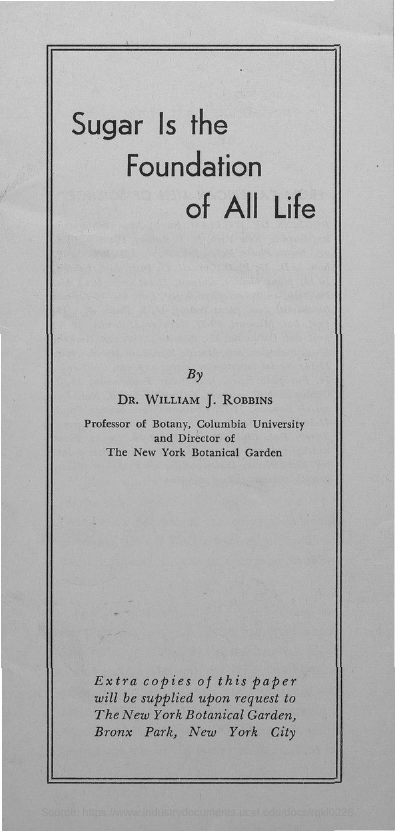What is the title of the document?
Ensure brevity in your answer.  Sugar is the foundation of all life. 